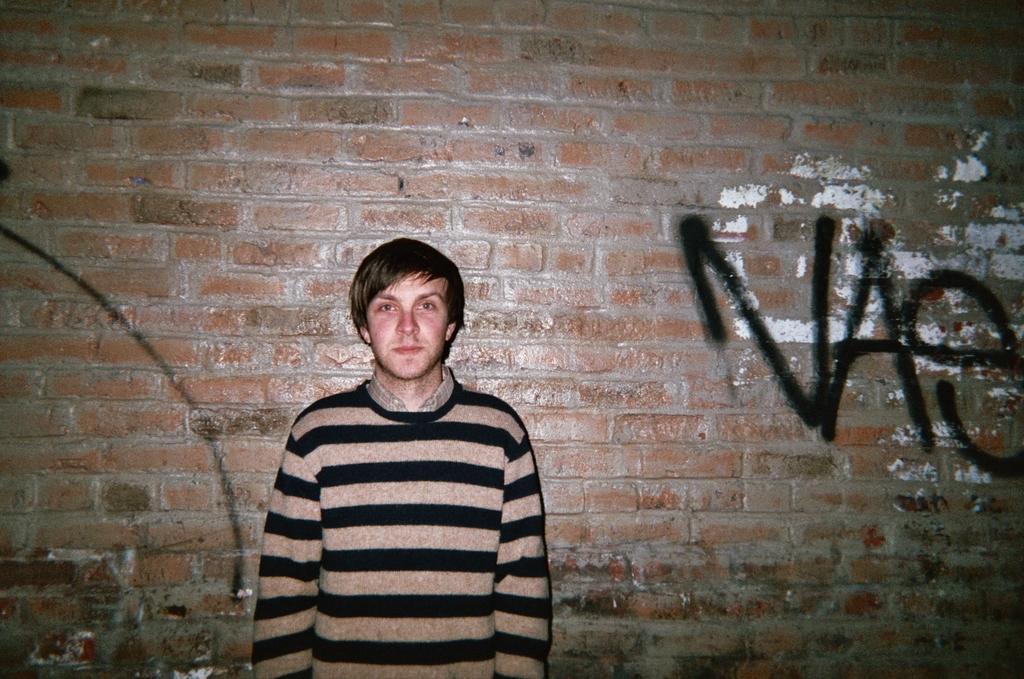How would you summarize this image in a sentence or two? In this image I can see a person wearing brown and black colored dress is standing and in the background I can see the wall which is made up of bricks and something is written on the wall with black color. 